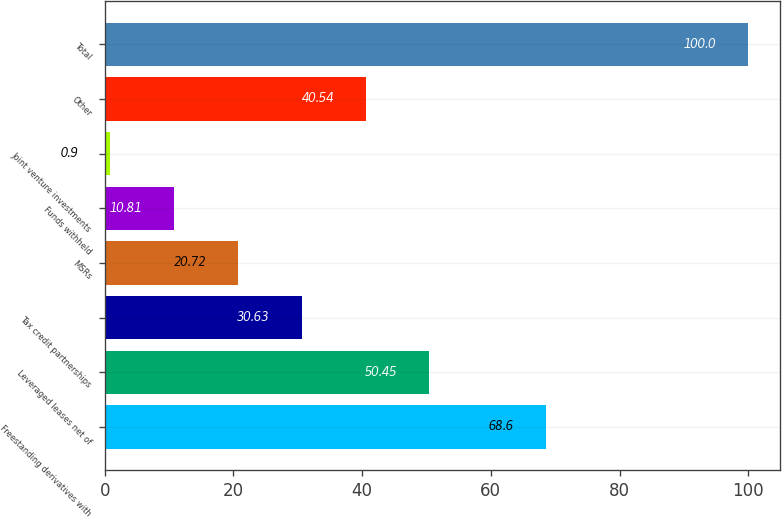Convert chart to OTSL. <chart><loc_0><loc_0><loc_500><loc_500><bar_chart><fcel>Freestanding derivatives with<fcel>Leveraged leases net of<fcel>Tax credit partnerships<fcel>MSRs<fcel>Funds withheld<fcel>Joint venture investments<fcel>Other<fcel>Total<nl><fcel>68.6<fcel>50.45<fcel>30.63<fcel>20.72<fcel>10.81<fcel>0.9<fcel>40.54<fcel>100<nl></chart> 